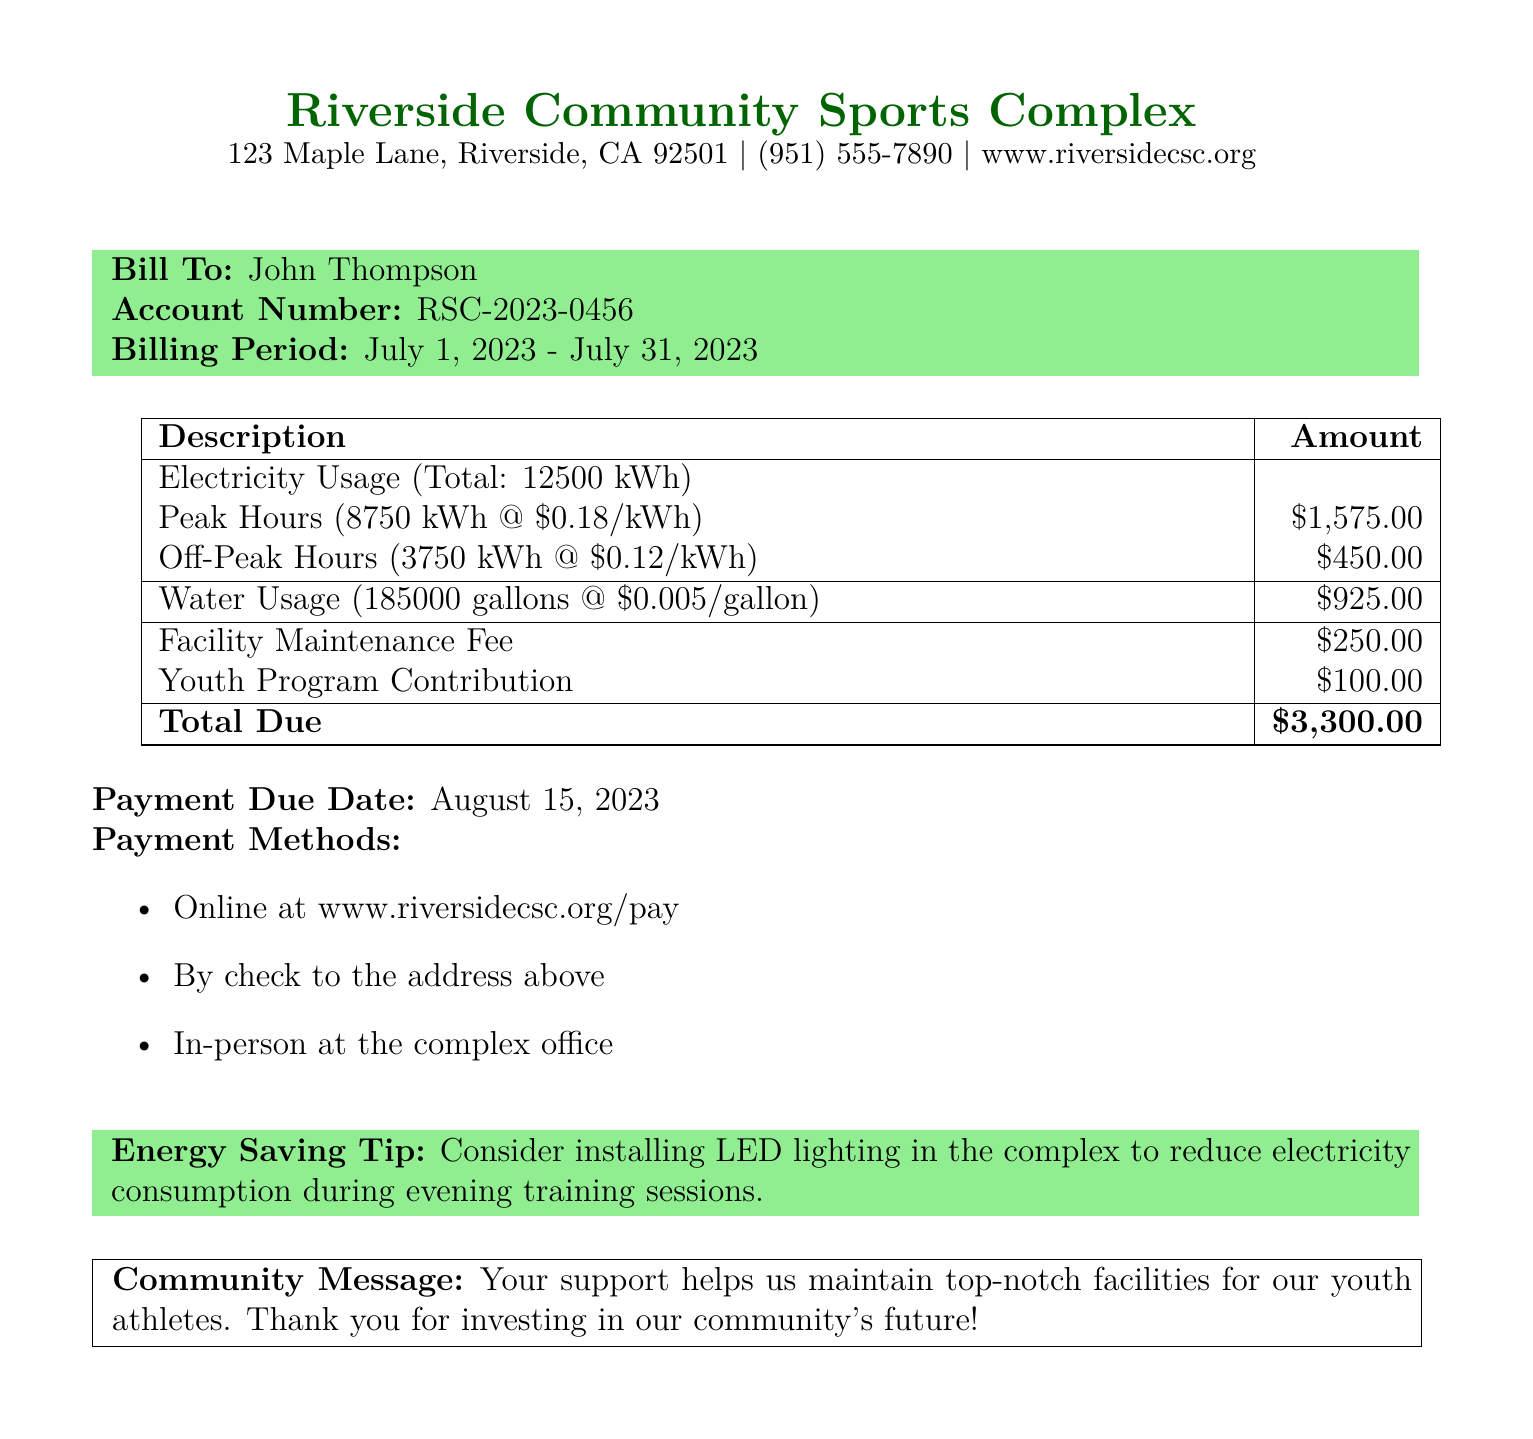What is the total amount due? The total amount due is listed at the bottom of the bill as the final amount.
Answer: $3,300.00 Who is the bill addressed to? The bill is addressed to a specific individual, as mentioned at the top of the billing section.
Answer: John Thompson What is the billing period? The billing period is indicated in the document and specifies the timeframe for the charges.
Answer: July 1, 2023 - July 31, 2023 How much was spent on water usage? The document provides a specific cost for water usage under the charges section.
Answer: $925.00 What is the electricity usage during peak hours? The bill details the amount of electricity used during peak hours in kilowatt-hours.
Answer: 8750 kWh What is the facility maintenance fee? The bill includes a specific fee associated with facility maintenance in the charges.
Answer: $250.00 When is the payment due? The document specifies a due date by which the payment must be made.
Answer: August 15, 2023 What is the Youth Program Contribution? The bill lists a contribution amount that supports youth programs, found within the charges.
Answer: $100.00 What is one energy-saving tip mentioned in the bill? The document offers a suggestion for reducing energy consumption related to lighting.
Answer: Install LED lighting 